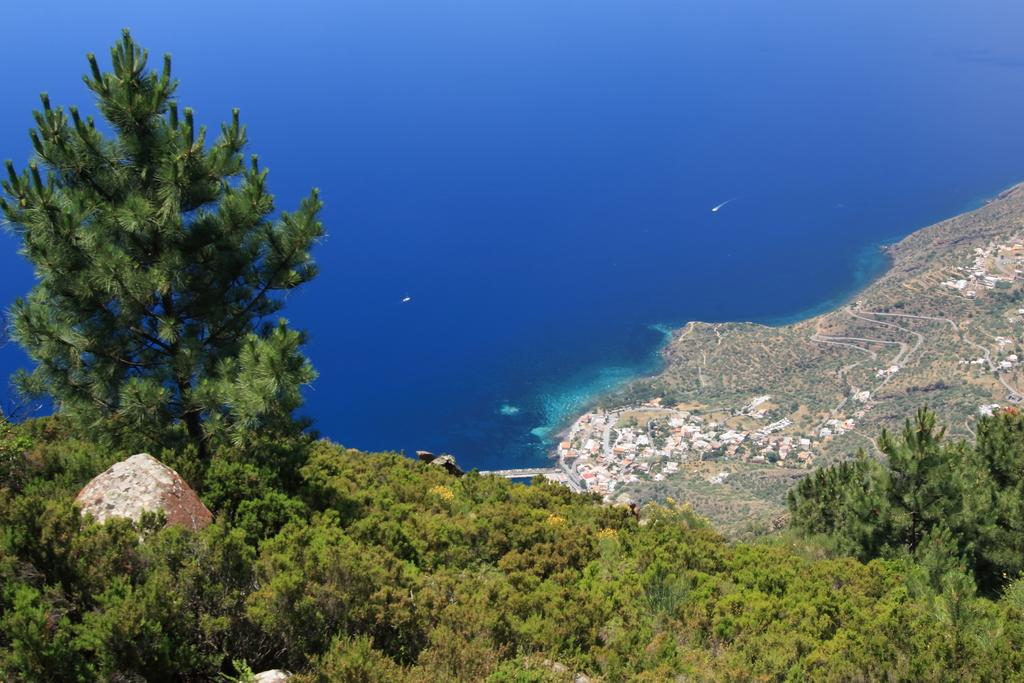What type of vegetation is at the bottom of the image? There are trees at the bottom of the image. What other object is present at the bottom of the image? There is a rock at the bottom of the image. What is the terrain behind the trees? There is ground with grass behind the trees. What else can be found on the ground with grass? There are other objects on the ground with grass. What is in front of the ground? There is water in front of the ground. Where are the scissors kept in the image? There are no scissors present in the image. What is stored in the cellar in the image? There is no cellar present in the image. 